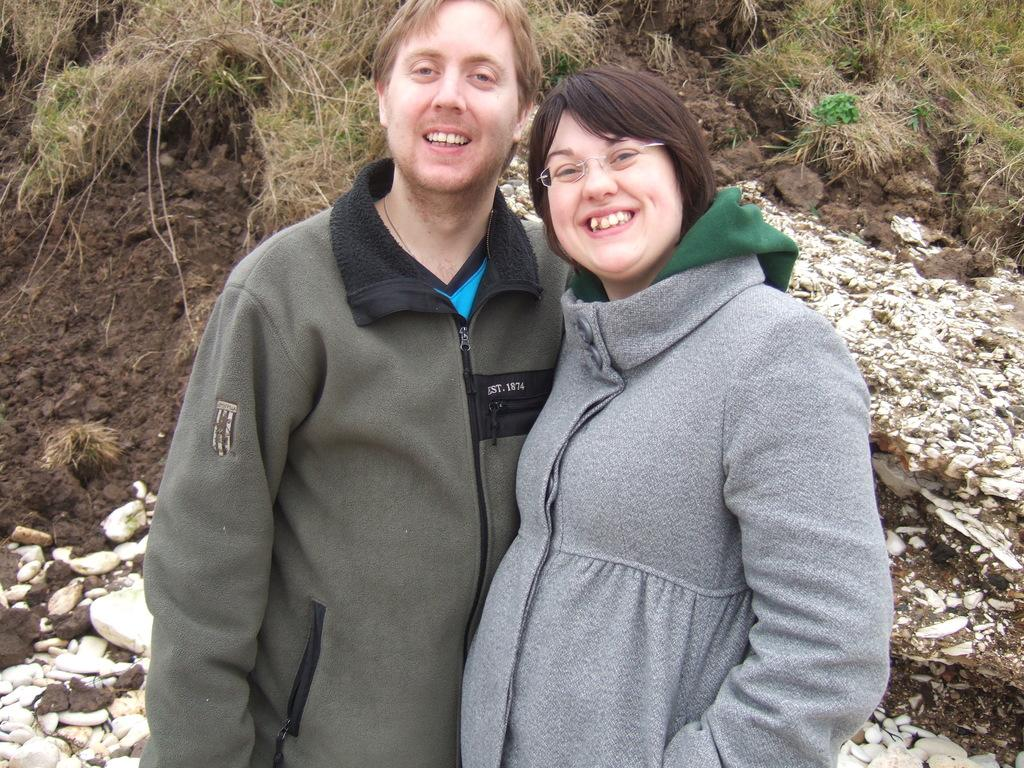How many people are in the image? There are two people in the image. Where are the two people located in the image? The two people are standing in the foreground. What are the two people doing in the image? The two people are laughing. What type of natural environment is visible in the background of the image? There is grass and soil visible in the background of the image. What type of bait is being used by the judge in the image? There is no judge or bait present in the image. How many carts are visible in the image? There are no carts visible in the image. 